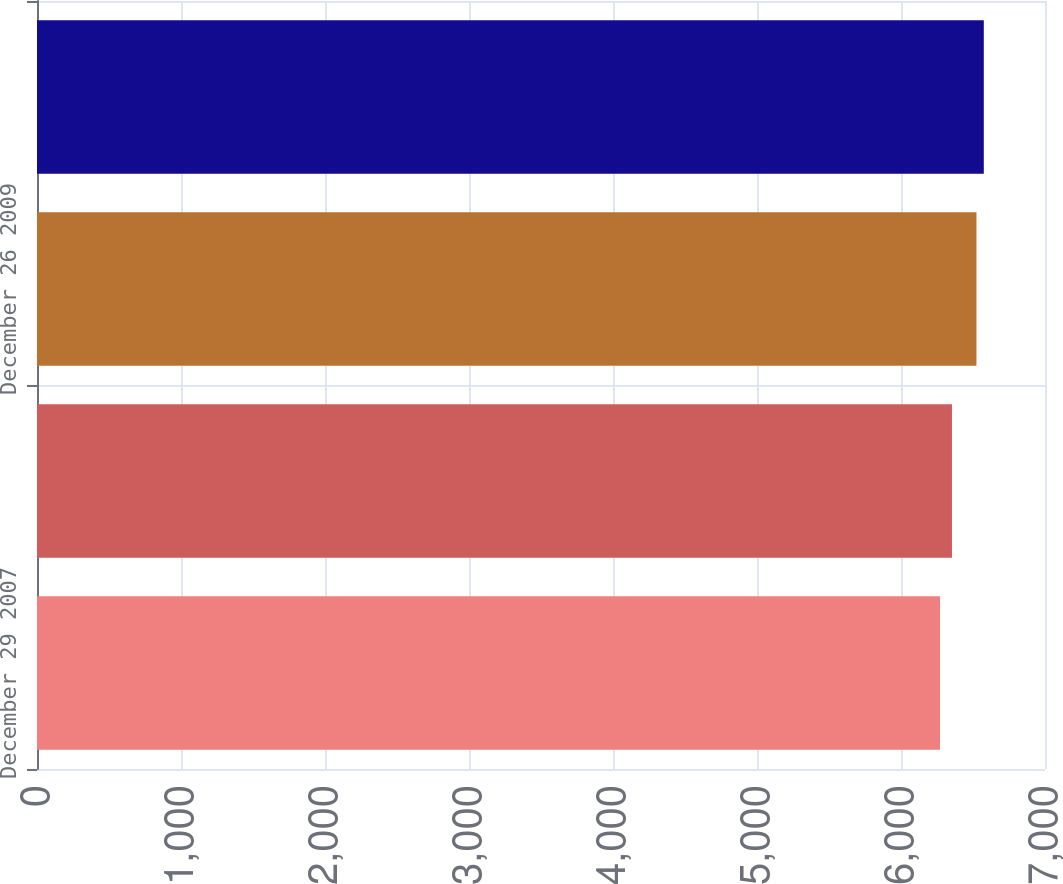Convert chart to OTSL. <chart><loc_0><loc_0><loc_500><loc_500><bar_chart><fcel>December 29 2007<fcel>December 27 2008<fcel>December 26 2009<fcel>December 25 2010<nl><fcel>6271<fcel>6354<fcel>6524<fcel>6575<nl></chart> 